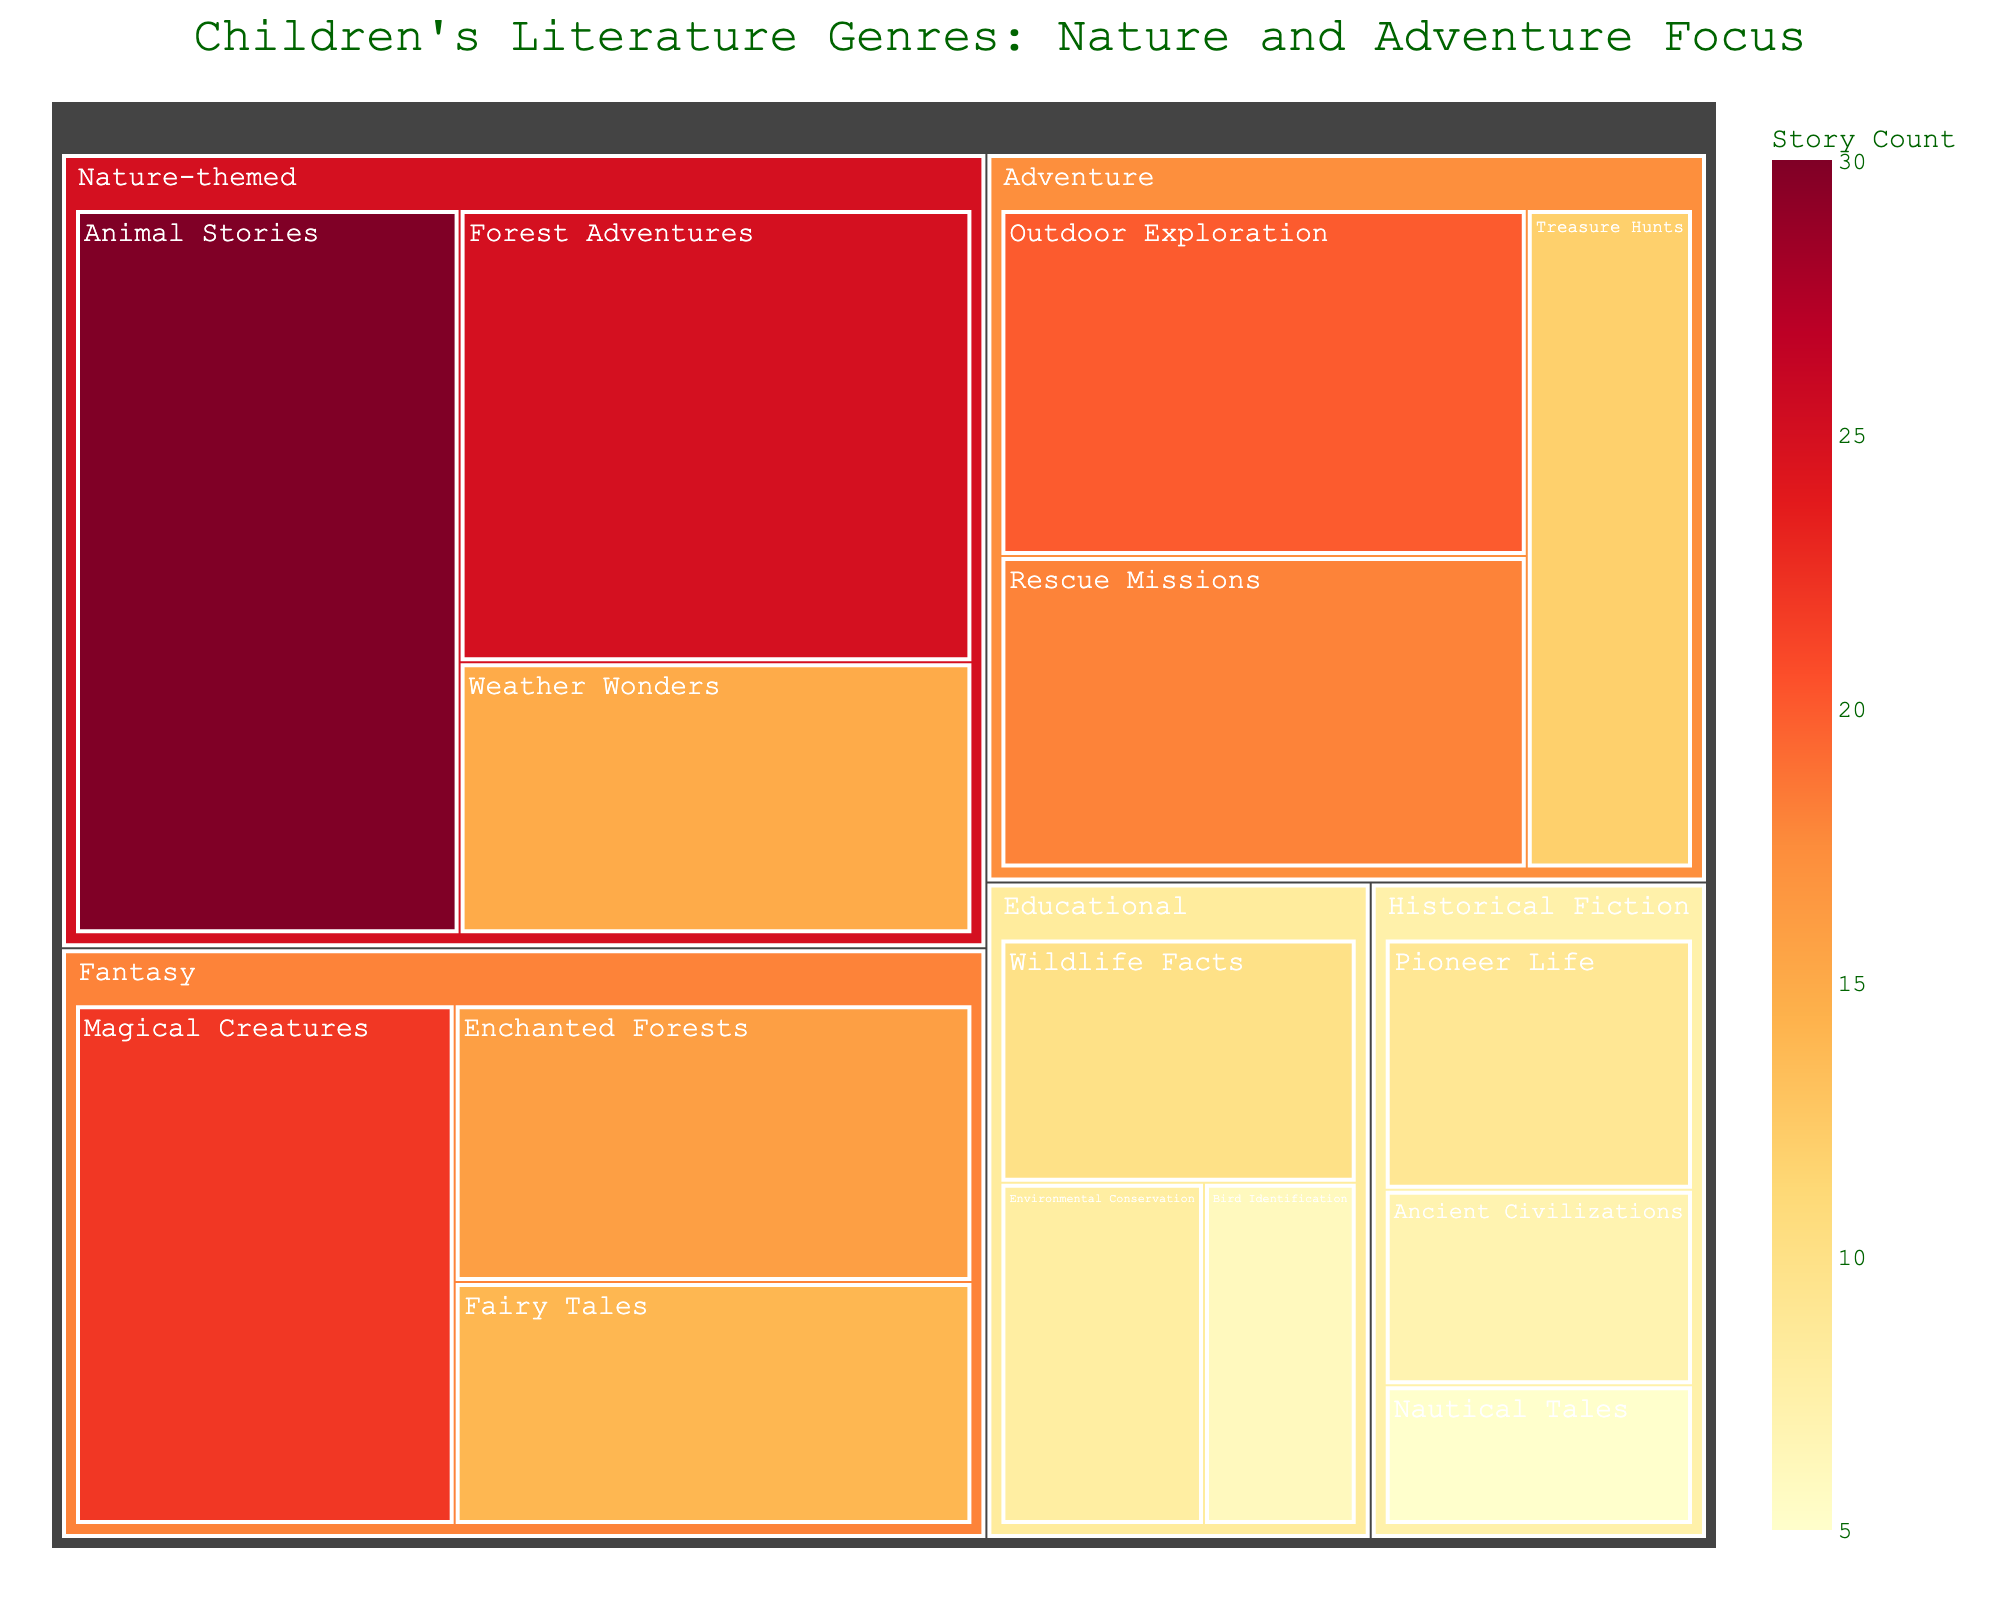What's the title of the treemap? The title provides a quick overview of what the figure represents, typically found at the top of the chart. In this case, it indicates the focus on genres within children's literature.
Answer: Children's Literature Genres: Nature and Adventure Focus What category has the highest story count? Each category's block size in the treemap reflects its story count. The largest block indicates the highest value.
Answer: Nature-themed Which subcategory within the Nature-themed category has the smallest story count? Within the Nature-themed category, compare the sizes of the subcategory blocks. The smallest block denotes the smallest story count.
Answer: Weather Wonders How many stories are in the Animal Stories subcategory? The story count is marked within each block. Locate the Animal Stories block in the Nature-themed category.
Answer: 30 What is the total story count for the Adventure category? Add the story counts of all subcategories under Adventure: Outdoor Exploration (20), Rescue Missions (18), and Treasure Hunts (12). 20 + 18 + 12 = 50.
Answer: 50 Which Adventure subcategory has more stories: Outdoor Exploration or Rescue Missions? Compare the story counts of the two subcategories within Adventure. Outdoor Exploration has 20 stories, while Rescue Missions has 18 stories. 20 > 18.
Answer: Outdoor Exploration What is the difference in story count between the largest and smallest subcategories overall? Identify the largest and smallest subcategories by comparing the story counts in each block. The largest is Animal Stories (30), and the smallest is Bird Identification (6). 30 - 6 = 24.
Answer: 24 Which category has the fewest stories overall? Compare the sizes of the main category blocks. The smallest block would be the one with the fewest stories. Since Educational, Wildlife Facts, at 10 stories, along with Environmental Conservation, and Bird Identification, has 6 stories, totally add up to 24. The others are greater.
Answer: Historical Fiction What is the combined story count for all nature-themed subcategories? Sum the story counts of Animal Stories (30), Forest Adventures (25), and Weather Wonders (15). 30 + 25 + 15 = 70.
Answer: 70 Which contains more stories: Fantasy or Historical Fiction? Compare the total stories in each subcategory under Fantasy and Historical Fiction. Fantasy has Magical Creatures (22), Enchanted Forests (16), and Fairy Tales (14), totaling 52. Historical Fiction has Pioneer Life (9), Ancient Civilizations (7), and Nautical Tales (5), totaling 21. 52 > 21.
Answer: Fantasy 